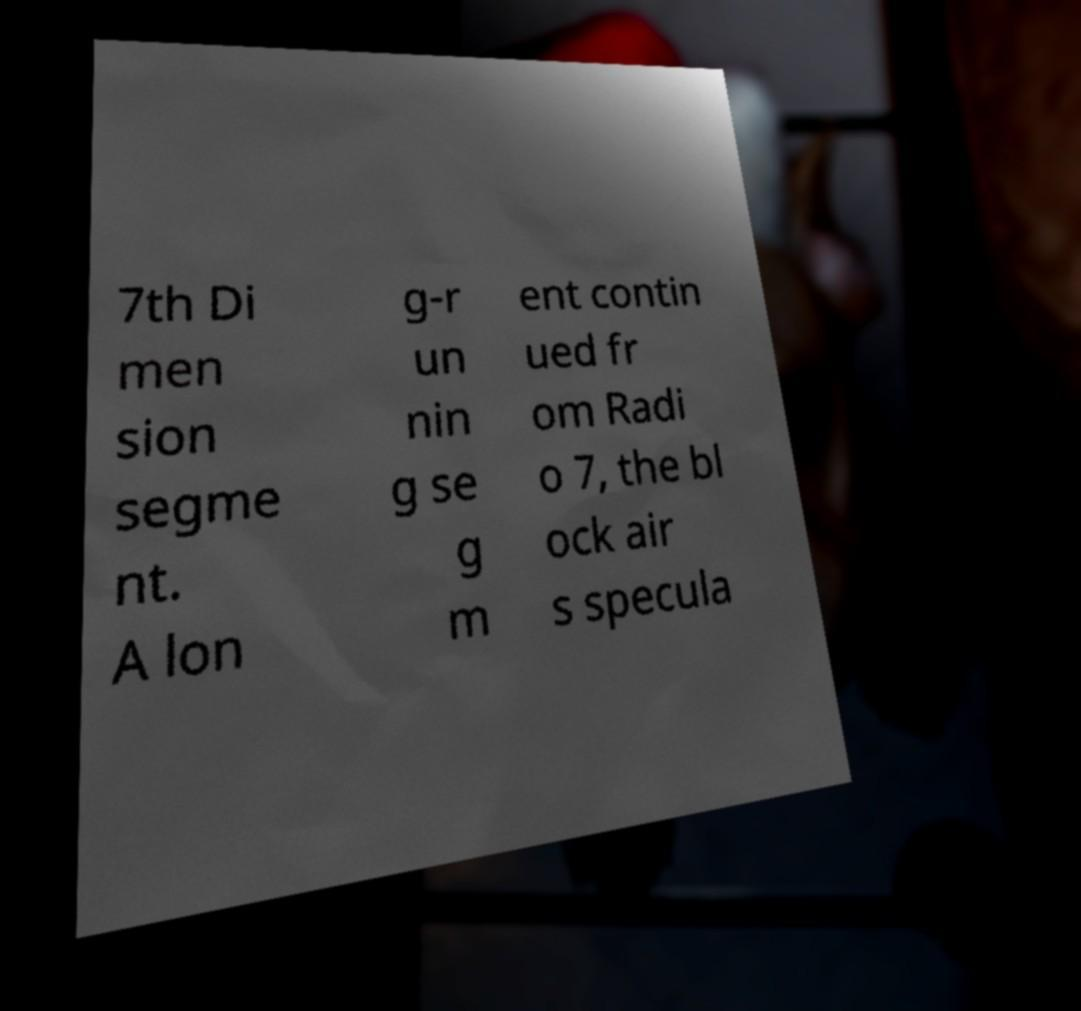Could you extract and type out the text from this image? 7th Di men sion segme nt. A lon g-r un nin g se g m ent contin ued fr om Radi o 7, the bl ock air s specula 